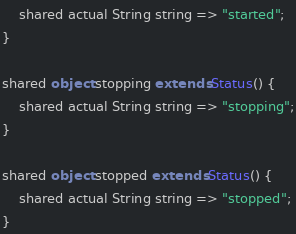Convert code to text. <code><loc_0><loc_0><loc_500><loc_500><_Ceylon_>    shared actual String string => "started";
}

shared object stopping extends Status() {
    shared actual String string => "stopping";
}

shared object stopped extends Status() {
    shared actual String string => "stopped";
}

</code> 